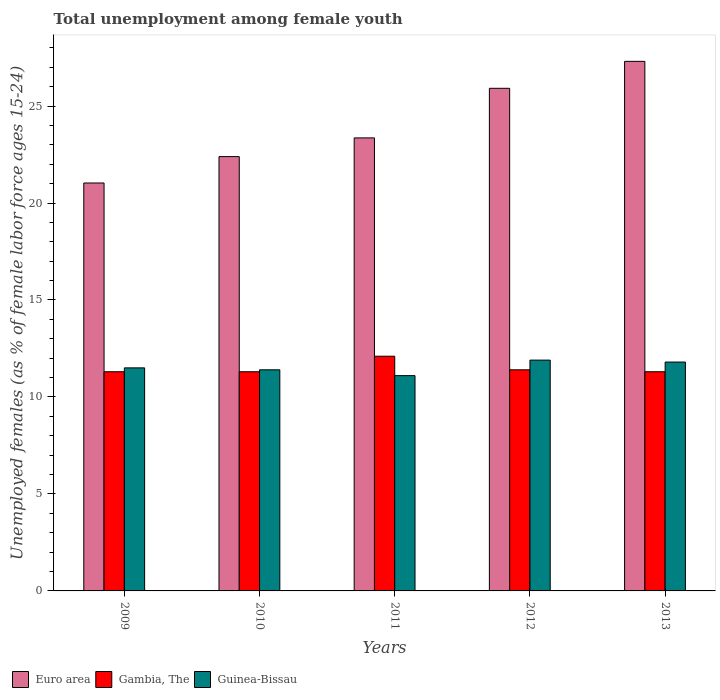How many groups of bars are there?
Make the answer very short. 5. Are the number of bars per tick equal to the number of legend labels?
Keep it short and to the point. Yes. Are the number of bars on each tick of the X-axis equal?
Make the answer very short. Yes. How many bars are there on the 5th tick from the left?
Keep it short and to the point. 3. How many bars are there on the 5th tick from the right?
Your answer should be compact. 3. What is the percentage of unemployed females in in Guinea-Bissau in 2012?
Provide a short and direct response. 11.9. Across all years, what is the maximum percentage of unemployed females in in Euro area?
Ensure brevity in your answer.  27.3. Across all years, what is the minimum percentage of unemployed females in in Gambia, The?
Your answer should be compact. 11.3. In which year was the percentage of unemployed females in in Euro area maximum?
Provide a short and direct response. 2013. What is the total percentage of unemployed females in in Gambia, The in the graph?
Provide a short and direct response. 57.4. What is the difference between the percentage of unemployed females in in Euro area in 2012 and that in 2013?
Provide a short and direct response. -1.39. What is the difference between the percentage of unemployed females in in Gambia, The in 2010 and the percentage of unemployed females in in Guinea-Bissau in 2009?
Keep it short and to the point. -0.2. What is the average percentage of unemployed females in in Guinea-Bissau per year?
Offer a terse response. 11.54. In the year 2010, what is the difference between the percentage of unemployed females in in Euro area and percentage of unemployed females in in Guinea-Bissau?
Make the answer very short. 10.99. What is the ratio of the percentage of unemployed females in in Euro area in 2010 to that in 2013?
Ensure brevity in your answer.  0.82. What is the difference between the highest and the second highest percentage of unemployed females in in Guinea-Bissau?
Make the answer very short. 0.1. What is the difference between the highest and the lowest percentage of unemployed females in in Euro area?
Offer a terse response. 6.27. In how many years, is the percentage of unemployed females in in Gambia, The greater than the average percentage of unemployed females in in Gambia, The taken over all years?
Offer a terse response. 1. Is the sum of the percentage of unemployed females in in Guinea-Bissau in 2010 and 2011 greater than the maximum percentage of unemployed females in in Euro area across all years?
Make the answer very short. No. Is it the case that in every year, the sum of the percentage of unemployed females in in Gambia, The and percentage of unemployed females in in Guinea-Bissau is greater than the percentage of unemployed females in in Euro area?
Keep it short and to the point. No. How many bars are there?
Your answer should be compact. 15. Are all the bars in the graph horizontal?
Ensure brevity in your answer.  No. What is the difference between two consecutive major ticks on the Y-axis?
Offer a terse response. 5. Are the values on the major ticks of Y-axis written in scientific E-notation?
Provide a succinct answer. No. Where does the legend appear in the graph?
Offer a terse response. Bottom left. How many legend labels are there?
Your answer should be very brief. 3. What is the title of the graph?
Your answer should be compact. Total unemployment among female youth. What is the label or title of the Y-axis?
Your response must be concise. Unemployed females (as % of female labor force ages 15-24). What is the Unemployed females (as % of female labor force ages 15-24) of Euro area in 2009?
Offer a very short reply. 21.03. What is the Unemployed females (as % of female labor force ages 15-24) of Gambia, The in 2009?
Provide a short and direct response. 11.3. What is the Unemployed females (as % of female labor force ages 15-24) of Guinea-Bissau in 2009?
Your answer should be compact. 11.5. What is the Unemployed females (as % of female labor force ages 15-24) of Euro area in 2010?
Your answer should be very brief. 22.39. What is the Unemployed females (as % of female labor force ages 15-24) of Gambia, The in 2010?
Make the answer very short. 11.3. What is the Unemployed females (as % of female labor force ages 15-24) of Guinea-Bissau in 2010?
Offer a very short reply. 11.4. What is the Unemployed females (as % of female labor force ages 15-24) in Euro area in 2011?
Your response must be concise. 23.36. What is the Unemployed females (as % of female labor force ages 15-24) of Gambia, The in 2011?
Keep it short and to the point. 12.1. What is the Unemployed females (as % of female labor force ages 15-24) in Guinea-Bissau in 2011?
Keep it short and to the point. 11.1. What is the Unemployed females (as % of female labor force ages 15-24) in Euro area in 2012?
Make the answer very short. 25.91. What is the Unemployed females (as % of female labor force ages 15-24) of Gambia, The in 2012?
Your answer should be compact. 11.4. What is the Unemployed females (as % of female labor force ages 15-24) in Guinea-Bissau in 2012?
Offer a very short reply. 11.9. What is the Unemployed females (as % of female labor force ages 15-24) of Euro area in 2013?
Give a very brief answer. 27.3. What is the Unemployed females (as % of female labor force ages 15-24) of Gambia, The in 2013?
Provide a short and direct response. 11.3. What is the Unemployed females (as % of female labor force ages 15-24) of Guinea-Bissau in 2013?
Ensure brevity in your answer.  11.8. Across all years, what is the maximum Unemployed females (as % of female labor force ages 15-24) of Euro area?
Your answer should be very brief. 27.3. Across all years, what is the maximum Unemployed females (as % of female labor force ages 15-24) in Gambia, The?
Your answer should be compact. 12.1. Across all years, what is the maximum Unemployed females (as % of female labor force ages 15-24) in Guinea-Bissau?
Offer a very short reply. 11.9. Across all years, what is the minimum Unemployed females (as % of female labor force ages 15-24) in Euro area?
Keep it short and to the point. 21.03. Across all years, what is the minimum Unemployed females (as % of female labor force ages 15-24) of Gambia, The?
Give a very brief answer. 11.3. Across all years, what is the minimum Unemployed females (as % of female labor force ages 15-24) of Guinea-Bissau?
Give a very brief answer. 11.1. What is the total Unemployed females (as % of female labor force ages 15-24) in Euro area in the graph?
Your response must be concise. 120. What is the total Unemployed females (as % of female labor force ages 15-24) in Gambia, The in the graph?
Ensure brevity in your answer.  57.4. What is the total Unemployed females (as % of female labor force ages 15-24) of Guinea-Bissau in the graph?
Keep it short and to the point. 57.7. What is the difference between the Unemployed females (as % of female labor force ages 15-24) in Euro area in 2009 and that in 2010?
Offer a very short reply. -1.36. What is the difference between the Unemployed females (as % of female labor force ages 15-24) of Gambia, The in 2009 and that in 2010?
Your answer should be very brief. 0. What is the difference between the Unemployed females (as % of female labor force ages 15-24) of Guinea-Bissau in 2009 and that in 2010?
Make the answer very short. 0.1. What is the difference between the Unemployed females (as % of female labor force ages 15-24) in Euro area in 2009 and that in 2011?
Give a very brief answer. -2.33. What is the difference between the Unemployed females (as % of female labor force ages 15-24) in Guinea-Bissau in 2009 and that in 2011?
Your answer should be very brief. 0.4. What is the difference between the Unemployed females (as % of female labor force ages 15-24) of Euro area in 2009 and that in 2012?
Make the answer very short. -4.88. What is the difference between the Unemployed females (as % of female labor force ages 15-24) in Euro area in 2009 and that in 2013?
Provide a succinct answer. -6.27. What is the difference between the Unemployed females (as % of female labor force ages 15-24) of Gambia, The in 2009 and that in 2013?
Provide a short and direct response. 0. What is the difference between the Unemployed females (as % of female labor force ages 15-24) in Euro area in 2010 and that in 2011?
Offer a very short reply. -0.97. What is the difference between the Unemployed females (as % of female labor force ages 15-24) in Guinea-Bissau in 2010 and that in 2011?
Provide a succinct answer. 0.3. What is the difference between the Unemployed females (as % of female labor force ages 15-24) in Euro area in 2010 and that in 2012?
Keep it short and to the point. -3.52. What is the difference between the Unemployed females (as % of female labor force ages 15-24) of Gambia, The in 2010 and that in 2012?
Ensure brevity in your answer.  -0.1. What is the difference between the Unemployed females (as % of female labor force ages 15-24) of Guinea-Bissau in 2010 and that in 2012?
Offer a terse response. -0.5. What is the difference between the Unemployed females (as % of female labor force ages 15-24) in Euro area in 2010 and that in 2013?
Provide a short and direct response. -4.91. What is the difference between the Unemployed females (as % of female labor force ages 15-24) of Gambia, The in 2010 and that in 2013?
Offer a terse response. 0. What is the difference between the Unemployed females (as % of female labor force ages 15-24) in Guinea-Bissau in 2010 and that in 2013?
Make the answer very short. -0.4. What is the difference between the Unemployed females (as % of female labor force ages 15-24) in Euro area in 2011 and that in 2012?
Make the answer very short. -2.56. What is the difference between the Unemployed females (as % of female labor force ages 15-24) of Gambia, The in 2011 and that in 2012?
Make the answer very short. 0.7. What is the difference between the Unemployed females (as % of female labor force ages 15-24) in Guinea-Bissau in 2011 and that in 2012?
Your answer should be compact. -0.8. What is the difference between the Unemployed females (as % of female labor force ages 15-24) in Euro area in 2011 and that in 2013?
Provide a short and direct response. -3.95. What is the difference between the Unemployed females (as % of female labor force ages 15-24) of Euro area in 2012 and that in 2013?
Make the answer very short. -1.39. What is the difference between the Unemployed females (as % of female labor force ages 15-24) of Guinea-Bissau in 2012 and that in 2013?
Your answer should be compact. 0.1. What is the difference between the Unemployed females (as % of female labor force ages 15-24) of Euro area in 2009 and the Unemployed females (as % of female labor force ages 15-24) of Gambia, The in 2010?
Offer a very short reply. 9.73. What is the difference between the Unemployed females (as % of female labor force ages 15-24) of Euro area in 2009 and the Unemployed females (as % of female labor force ages 15-24) of Guinea-Bissau in 2010?
Give a very brief answer. 9.63. What is the difference between the Unemployed females (as % of female labor force ages 15-24) of Gambia, The in 2009 and the Unemployed females (as % of female labor force ages 15-24) of Guinea-Bissau in 2010?
Offer a very short reply. -0.1. What is the difference between the Unemployed females (as % of female labor force ages 15-24) of Euro area in 2009 and the Unemployed females (as % of female labor force ages 15-24) of Gambia, The in 2011?
Your response must be concise. 8.93. What is the difference between the Unemployed females (as % of female labor force ages 15-24) of Euro area in 2009 and the Unemployed females (as % of female labor force ages 15-24) of Guinea-Bissau in 2011?
Keep it short and to the point. 9.93. What is the difference between the Unemployed females (as % of female labor force ages 15-24) of Euro area in 2009 and the Unemployed females (as % of female labor force ages 15-24) of Gambia, The in 2012?
Your answer should be compact. 9.63. What is the difference between the Unemployed females (as % of female labor force ages 15-24) in Euro area in 2009 and the Unemployed females (as % of female labor force ages 15-24) in Guinea-Bissau in 2012?
Offer a very short reply. 9.13. What is the difference between the Unemployed females (as % of female labor force ages 15-24) in Euro area in 2009 and the Unemployed females (as % of female labor force ages 15-24) in Gambia, The in 2013?
Make the answer very short. 9.73. What is the difference between the Unemployed females (as % of female labor force ages 15-24) of Euro area in 2009 and the Unemployed females (as % of female labor force ages 15-24) of Guinea-Bissau in 2013?
Your answer should be very brief. 9.23. What is the difference between the Unemployed females (as % of female labor force ages 15-24) of Gambia, The in 2009 and the Unemployed females (as % of female labor force ages 15-24) of Guinea-Bissau in 2013?
Give a very brief answer. -0.5. What is the difference between the Unemployed females (as % of female labor force ages 15-24) in Euro area in 2010 and the Unemployed females (as % of female labor force ages 15-24) in Gambia, The in 2011?
Your answer should be compact. 10.29. What is the difference between the Unemployed females (as % of female labor force ages 15-24) in Euro area in 2010 and the Unemployed females (as % of female labor force ages 15-24) in Guinea-Bissau in 2011?
Offer a terse response. 11.29. What is the difference between the Unemployed females (as % of female labor force ages 15-24) of Euro area in 2010 and the Unemployed females (as % of female labor force ages 15-24) of Gambia, The in 2012?
Your answer should be very brief. 10.99. What is the difference between the Unemployed females (as % of female labor force ages 15-24) of Euro area in 2010 and the Unemployed females (as % of female labor force ages 15-24) of Guinea-Bissau in 2012?
Your response must be concise. 10.49. What is the difference between the Unemployed females (as % of female labor force ages 15-24) in Gambia, The in 2010 and the Unemployed females (as % of female labor force ages 15-24) in Guinea-Bissau in 2012?
Your response must be concise. -0.6. What is the difference between the Unemployed females (as % of female labor force ages 15-24) in Euro area in 2010 and the Unemployed females (as % of female labor force ages 15-24) in Gambia, The in 2013?
Your response must be concise. 11.09. What is the difference between the Unemployed females (as % of female labor force ages 15-24) in Euro area in 2010 and the Unemployed females (as % of female labor force ages 15-24) in Guinea-Bissau in 2013?
Offer a very short reply. 10.59. What is the difference between the Unemployed females (as % of female labor force ages 15-24) in Gambia, The in 2010 and the Unemployed females (as % of female labor force ages 15-24) in Guinea-Bissau in 2013?
Your answer should be very brief. -0.5. What is the difference between the Unemployed females (as % of female labor force ages 15-24) of Euro area in 2011 and the Unemployed females (as % of female labor force ages 15-24) of Gambia, The in 2012?
Offer a terse response. 11.96. What is the difference between the Unemployed females (as % of female labor force ages 15-24) of Euro area in 2011 and the Unemployed females (as % of female labor force ages 15-24) of Guinea-Bissau in 2012?
Your answer should be compact. 11.46. What is the difference between the Unemployed females (as % of female labor force ages 15-24) in Euro area in 2011 and the Unemployed females (as % of female labor force ages 15-24) in Gambia, The in 2013?
Provide a succinct answer. 12.06. What is the difference between the Unemployed females (as % of female labor force ages 15-24) in Euro area in 2011 and the Unemployed females (as % of female labor force ages 15-24) in Guinea-Bissau in 2013?
Make the answer very short. 11.56. What is the difference between the Unemployed females (as % of female labor force ages 15-24) in Euro area in 2012 and the Unemployed females (as % of female labor force ages 15-24) in Gambia, The in 2013?
Give a very brief answer. 14.61. What is the difference between the Unemployed females (as % of female labor force ages 15-24) of Euro area in 2012 and the Unemployed females (as % of female labor force ages 15-24) of Guinea-Bissau in 2013?
Your answer should be very brief. 14.11. What is the difference between the Unemployed females (as % of female labor force ages 15-24) of Gambia, The in 2012 and the Unemployed females (as % of female labor force ages 15-24) of Guinea-Bissau in 2013?
Provide a succinct answer. -0.4. What is the average Unemployed females (as % of female labor force ages 15-24) of Euro area per year?
Your answer should be very brief. 24. What is the average Unemployed females (as % of female labor force ages 15-24) in Gambia, The per year?
Your answer should be very brief. 11.48. What is the average Unemployed females (as % of female labor force ages 15-24) of Guinea-Bissau per year?
Your response must be concise. 11.54. In the year 2009, what is the difference between the Unemployed females (as % of female labor force ages 15-24) of Euro area and Unemployed females (as % of female labor force ages 15-24) of Gambia, The?
Your answer should be compact. 9.73. In the year 2009, what is the difference between the Unemployed females (as % of female labor force ages 15-24) in Euro area and Unemployed females (as % of female labor force ages 15-24) in Guinea-Bissau?
Your answer should be compact. 9.53. In the year 2010, what is the difference between the Unemployed females (as % of female labor force ages 15-24) in Euro area and Unemployed females (as % of female labor force ages 15-24) in Gambia, The?
Make the answer very short. 11.09. In the year 2010, what is the difference between the Unemployed females (as % of female labor force ages 15-24) in Euro area and Unemployed females (as % of female labor force ages 15-24) in Guinea-Bissau?
Make the answer very short. 10.99. In the year 2011, what is the difference between the Unemployed females (as % of female labor force ages 15-24) of Euro area and Unemployed females (as % of female labor force ages 15-24) of Gambia, The?
Your response must be concise. 11.26. In the year 2011, what is the difference between the Unemployed females (as % of female labor force ages 15-24) of Euro area and Unemployed females (as % of female labor force ages 15-24) of Guinea-Bissau?
Ensure brevity in your answer.  12.26. In the year 2011, what is the difference between the Unemployed females (as % of female labor force ages 15-24) of Gambia, The and Unemployed females (as % of female labor force ages 15-24) of Guinea-Bissau?
Offer a terse response. 1. In the year 2012, what is the difference between the Unemployed females (as % of female labor force ages 15-24) in Euro area and Unemployed females (as % of female labor force ages 15-24) in Gambia, The?
Your response must be concise. 14.51. In the year 2012, what is the difference between the Unemployed females (as % of female labor force ages 15-24) of Euro area and Unemployed females (as % of female labor force ages 15-24) of Guinea-Bissau?
Give a very brief answer. 14.01. In the year 2013, what is the difference between the Unemployed females (as % of female labor force ages 15-24) in Euro area and Unemployed females (as % of female labor force ages 15-24) in Gambia, The?
Offer a terse response. 16. In the year 2013, what is the difference between the Unemployed females (as % of female labor force ages 15-24) in Euro area and Unemployed females (as % of female labor force ages 15-24) in Guinea-Bissau?
Provide a short and direct response. 15.5. What is the ratio of the Unemployed females (as % of female labor force ages 15-24) of Euro area in 2009 to that in 2010?
Make the answer very short. 0.94. What is the ratio of the Unemployed females (as % of female labor force ages 15-24) of Gambia, The in 2009 to that in 2010?
Provide a short and direct response. 1. What is the ratio of the Unemployed females (as % of female labor force ages 15-24) in Guinea-Bissau in 2009 to that in 2010?
Your answer should be very brief. 1.01. What is the ratio of the Unemployed females (as % of female labor force ages 15-24) in Euro area in 2009 to that in 2011?
Offer a very short reply. 0.9. What is the ratio of the Unemployed females (as % of female labor force ages 15-24) in Gambia, The in 2009 to that in 2011?
Your response must be concise. 0.93. What is the ratio of the Unemployed females (as % of female labor force ages 15-24) in Guinea-Bissau in 2009 to that in 2011?
Keep it short and to the point. 1.04. What is the ratio of the Unemployed females (as % of female labor force ages 15-24) in Euro area in 2009 to that in 2012?
Your answer should be very brief. 0.81. What is the ratio of the Unemployed females (as % of female labor force ages 15-24) of Gambia, The in 2009 to that in 2012?
Your response must be concise. 0.99. What is the ratio of the Unemployed females (as % of female labor force ages 15-24) of Guinea-Bissau in 2009 to that in 2012?
Give a very brief answer. 0.97. What is the ratio of the Unemployed females (as % of female labor force ages 15-24) in Euro area in 2009 to that in 2013?
Your answer should be compact. 0.77. What is the ratio of the Unemployed females (as % of female labor force ages 15-24) of Gambia, The in 2009 to that in 2013?
Keep it short and to the point. 1. What is the ratio of the Unemployed females (as % of female labor force ages 15-24) in Guinea-Bissau in 2009 to that in 2013?
Keep it short and to the point. 0.97. What is the ratio of the Unemployed females (as % of female labor force ages 15-24) in Euro area in 2010 to that in 2011?
Provide a succinct answer. 0.96. What is the ratio of the Unemployed females (as % of female labor force ages 15-24) in Gambia, The in 2010 to that in 2011?
Keep it short and to the point. 0.93. What is the ratio of the Unemployed females (as % of female labor force ages 15-24) in Euro area in 2010 to that in 2012?
Make the answer very short. 0.86. What is the ratio of the Unemployed females (as % of female labor force ages 15-24) of Guinea-Bissau in 2010 to that in 2012?
Provide a short and direct response. 0.96. What is the ratio of the Unemployed females (as % of female labor force ages 15-24) in Euro area in 2010 to that in 2013?
Your answer should be compact. 0.82. What is the ratio of the Unemployed females (as % of female labor force ages 15-24) in Guinea-Bissau in 2010 to that in 2013?
Make the answer very short. 0.97. What is the ratio of the Unemployed females (as % of female labor force ages 15-24) in Euro area in 2011 to that in 2012?
Your answer should be very brief. 0.9. What is the ratio of the Unemployed females (as % of female labor force ages 15-24) of Gambia, The in 2011 to that in 2012?
Ensure brevity in your answer.  1.06. What is the ratio of the Unemployed females (as % of female labor force ages 15-24) in Guinea-Bissau in 2011 to that in 2012?
Give a very brief answer. 0.93. What is the ratio of the Unemployed females (as % of female labor force ages 15-24) of Euro area in 2011 to that in 2013?
Your answer should be very brief. 0.86. What is the ratio of the Unemployed females (as % of female labor force ages 15-24) in Gambia, The in 2011 to that in 2013?
Your answer should be very brief. 1.07. What is the ratio of the Unemployed females (as % of female labor force ages 15-24) in Guinea-Bissau in 2011 to that in 2013?
Provide a short and direct response. 0.94. What is the ratio of the Unemployed females (as % of female labor force ages 15-24) in Euro area in 2012 to that in 2013?
Your answer should be compact. 0.95. What is the ratio of the Unemployed females (as % of female labor force ages 15-24) in Gambia, The in 2012 to that in 2013?
Your response must be concise. 1.01. What is the ratio of the Unemployed females (as % of female labor force ages 15-24) in Guinea-Bissau in 2012 to that in 2013?
Offer a terse response. 1.01. What is the difference between the highest and the second highest Unemployed females (as % of female labor force ages 15-24) of Euro area?
Keep it short and to the point. 1.39. What is the difference between the highest and the second highest Unemployed females (as % of female labor force ages 15-24) in Guinea-Bissau?
Keep it short and to the point. 0.1. What is the difference between the highest and the lowest Unemployed females (as % of female labor force ages 15-24) in Euro area?
Offer a terse response. 6.27. What is the difference between the highest and the lowest Unemployed females (as % of female labor force ages 15-24) of Guinea-Bissau?
Give a very brief answer. 0.8. 